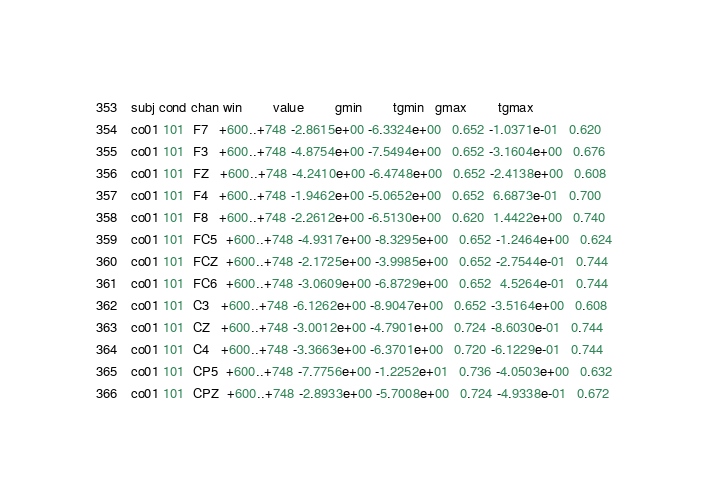Convert code to text. <code><loc_0><loc_0><loc_500><loc_500><_SQL_>subj cond chan win        value        gmin        tgmin   gmax        tgmax  
co01 101  F7   +600..+748 -2.8615e+00 -6.3324e+00   0.652 -1.0371e-01   0.620
co01 101  F3   +600..+748 -4.8754e+00 -7.5494e+00   0.652 -3.1604e+00   0.676
co01 101  FZ   +600..+748 -4.2410e+00 -6.4748e+00   0.652 -2.4138e+00   0.608
co01 101  F4   +600..+748 -1.9462e+00 -5.0652e+00   0.652  6.6873e-01   0.700
co01 101  F8   +600..+748 -2.2612e+00 -6.5130e+00   0.620  1.4422e+00   0.740
co01 101  FC5  +600..+748 -4.9317e+00 -8.3295e+00   0.652 -1.2464e+00   0.624
co01 101  FCZ  +600..+748 -2.1725e+00 -3.9985e+00   0.652 -2.7544e-01   0.744
co01 101  FC6  +600..+748 -3.0609e+00 -6.8729e+00   0.652  4.5264e-01   0.744
co01 101  C3   +600..+748 -6.1262e+00 -8.9047e+00   0.652 -3.5164e+00   0.608
co01 101  CZ   +600..+748 -3.0012e+00 -4.7901e+00   0.724 -8.6030e-01   0.744
co01 101  C4   +600..+748 -3.3663e+00 -6.3701e+00   0.720 -6.1229e-01   0.744
co01 101  CP5  +600..+748 -7.7756e+00 -1.2252e+01   0.736 -4.0503e+00   0.632
co01 101  CPZ  +600..+748 -2.8933e+00 -5.7008e+00   0.724 -4.9338e-01   0.672</code> 